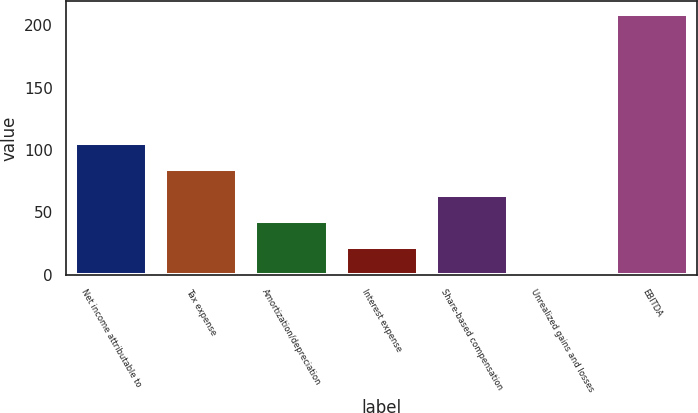<chart> <loc_0><loc_0><loc_500><loc_500><bar_chart><fcel>Net income attributable to<fcel>Tax expense<fcel>Amortization/depreciation<fcel>Interest expense<fcel>Share-based compensation<fcel>Unrealized gains and losses<fcel>EBITDA<nl><fcel>105.2<fcel>84.32<fcel>42.86<fcel>22.13<fcel>63.59<fcel>1.4<fcel>208.7<nl></chart> 